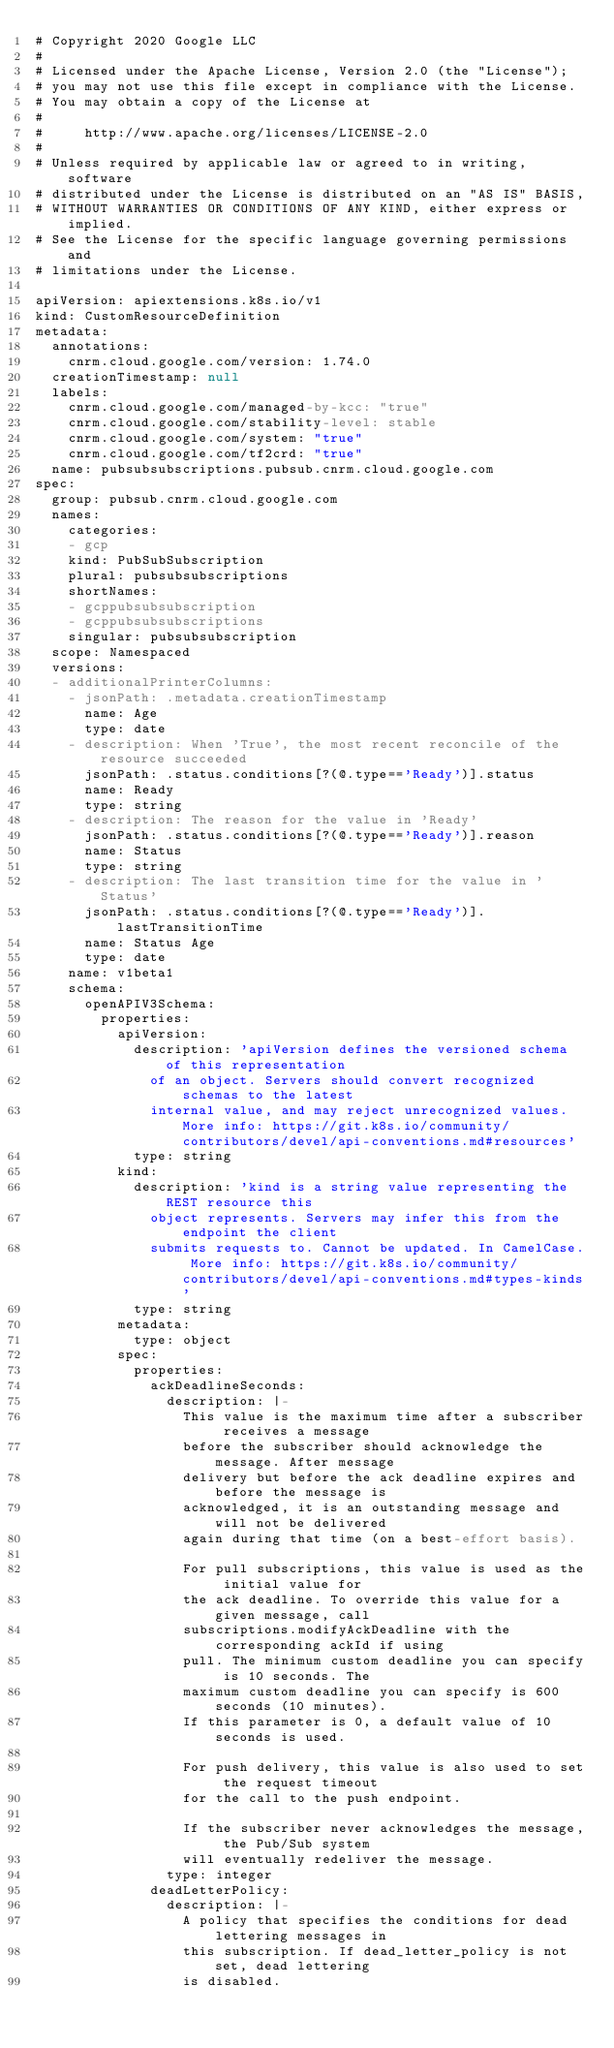<code> <loc_0><loc_0><loc_500><loc_500><_YAML_># Copyright 2020 Google LLC
#
# Licensed under the Apache License, Version 2.0 (the "License");
# you may not use this file except in compliance with the License.
# You may obtain a copy of the License at
#
#     http://www.apache.org/licenses/LICENSE-2.0
#
# Unless required by applicable law or agreed to in writing, software
# distributed under the License is distributed on an "AS IS" BASIS,
# WITHOUT WARRANTIES OR CONDITIONS OF ANY KIND, either express or implied.
# See the License for the specific language governing permissions and
# limitations under the License.

apiVersion: apiextensions.k8s.io/v1
kind: CustomResourceDefinition
metadata:
  annotations:
    cnrm.cloud.google.com/version: 1.74.0
  creationTimestamp: null
  labels:
    cnrm.cloud.google.com/managed-by-kcc: "true"
    cnrm.cloud.google.com/stability-level: stable
    cnrm.cloud.google.com/system: "true"
    cnrm.cloud.google.com/tf2crd: "true"
  name: pubsubsubscriptions.pubsub.cnrm.cloud.google.com
spec:
  group: pubsub.cnrm.cloud.google.com
  names:
    categories:
    - gcp
    kind: PubSubSubscription
    plural: pubsubsubscriptions
    shortNames:
    - gcppubsubsubscription
    - gcppubsubsubscriptions
    singular: pubsubsubscription
  scope: Namespaced
  versions:
  - additionalPrinterColumns:
    - jsonPath: .metadata.creationTimestamp
      name: Age
      type: date
    - description: When 'True', the most recent reconcile of the resource succeeded
      jsonPath: .status.conditions[?(@.type=='Ready')].status
      name: Ready
      type: string
    - description: The reason for the value in 'Ready'
      jsonPath: .status.conditions[?(@.type=='Ready')].reason
      name: Status
      type: string
    - description: The last transition time for the value in 'Status'
      jsonPath: .status.conditions[?(@.type=='Ready')].lastTransitionTime
      name: Status Age
      type: date
    name: v1beta1
    schema:
      openAPIV3Schema:
        properties:
          apiVersion:
            description: 'apiVersion defines the versioned schema of this representation
              of an object. Servers should convert recognized schemas to the latest
              internal value, and may reject unrecognized values. More info: https://git.k8s.io/community/contributors/devel/api-conventions.md#resources'
            type: string
          kind:
            description: 'kind is a string value representing the REST resource this
              object represents. Servers may infer this from the endpoint the client
              submits requests to. Cannot be updated. In CamelCase. More info: https://git.k8s.io/community/contributors/devel/api-conventions.md#types-kinds'
            type: string
          metadata:
            type: object
          spec:
            properties:
              ackDeadlineSeconds:
                description: |-
                  This value is the maximum time after a subscriber receives a message
                  before the subscriber should acknowledge the message. After message
                  delivery but before the ack deadline expires and before the message is
                  acknowledged, it is an outstanding message and will not be delivered
                  again during that time (on a best-effort basis).

                  For pull subscriptions, this value is used as the initial value for
                  the ack deadline. To override this value for a given message, call
                  subscriptions.modifyAckDeadline with the corresponding ackId if using
                  pull. The minimum custom deadline you can specify is 10 seconds. The
                  maximum custom deadline you can specify is 600 seconds (10 minutes).
                  If this parameter is 0, a default value of 10 seconds is used.

                  For push delivery, this value is also used to set the request timeout
                  for the call to the push endpoint.

                  If the subscriber never acknowledges the message, the Pub/Sub system
                  will eventually redeliver the message.
                type: integer
              deadLetterPolicy:
                description: |-
                  A policy that specifies the conditions for dead lettering messages in
                  this subscription. If dead_letter_policy is not set, dead lettering
                  is disabled.
</code> 